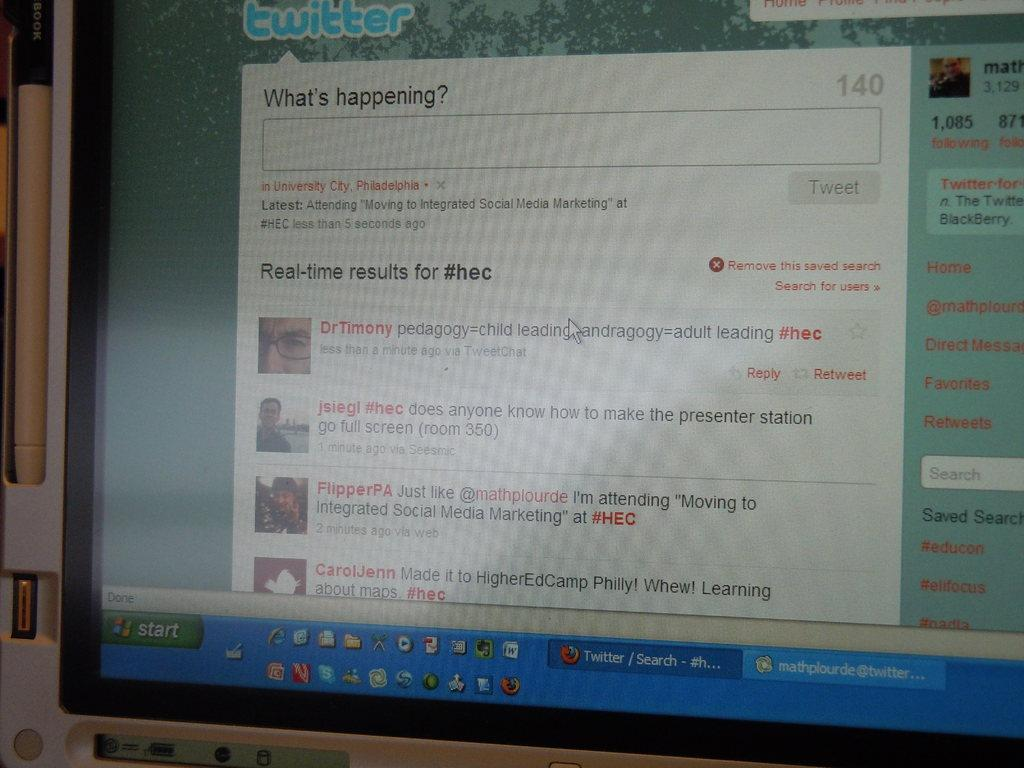<image>
Write a terse but informative summary of the picture. A computer monitor labeled Twitter displaying a screen asking "What's happening?" 